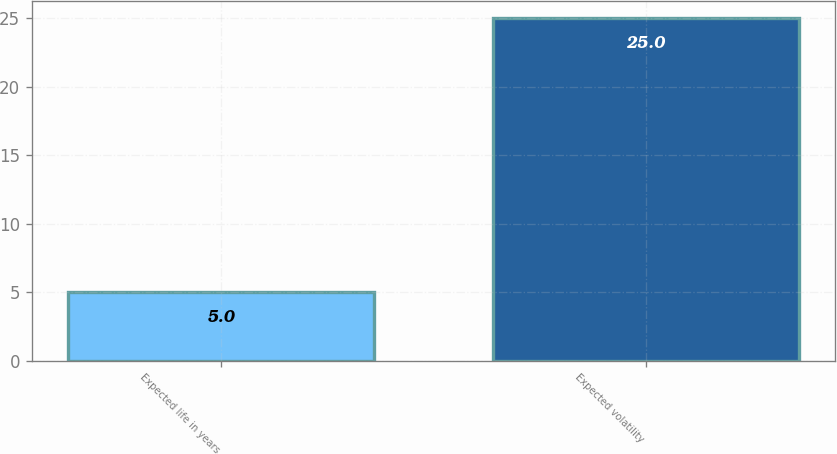Convert chart. <chart><loc_0><loc_0><loc_500><loc_500><bar_chart><fcel>Expected life in years<fcel>Expected volatility<nl><fcel>5<fcel>25<nl></chart> 